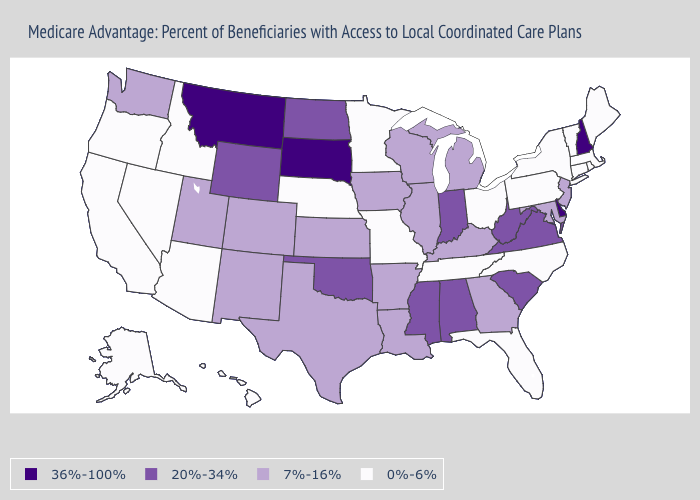What is the value of New Mexico?
Keep it brief. 7%-16%. Name the states that have a value in the range 0%-6%?
Short answer required. Alaska, Arizona, California, Connecticut, Florida, Hawaii, Idaho, Massachusetts, Maine, Minnesota, Missouri, North Carolina, Nebraska, Nevada, New York, Ohio, Oregon, Pennsylvania, Rhode Island, Tennessee, Vermont. Name the states that have a value in the range 0%-6%?
Keep it brief. Alaska, Arizona, California, Connecticut, Florida, Hawaii, Idaho, Massachusetts, Maine, Minnesota, Missouri, North Carolina, Nebraska, Nevada, New York, Ohio, Oregon, Pennsylvania, Rhode Island, Tennessee, Vermont. Which states hav the highest value in the West?
Write a very short answer. Montana. Which states have the lowest value in the USA?
Keep it brief. Alaska, Arizona, California, Connecticut, Florida, Hawaii, Idaho, Massachusetts, Maine, Minnesota, Missouri, North Carolina, Nebraska, Nevada, New York, Ohio, Oregon, Pennsylvania, Rhode Island, Tennessee, Vermont. Name the states that have a value in the range 0%-6%?
Write a very short answer. Alaska, Arizona, California, Connecticut, Florida, Hawaii, Idaho, Massachusetts, Maine, Minnesota, Missouri, North Carolina, Nebraska, Nevada, New York, Ohio, Oregon, Pennsylvania, Rhode Island, Tennessee, Vermont. What is the lowest value in the MidWest?
Answer briefly. 0%-6%. Among the states that border Iowa , does South Dakota have the highest value?
Write a very short answer. Yes. Which states have the lowest value in the West?
Answer briefly. Alaska, Arizona, California, Hawaii, Idaho, Nevada, Oregon. Name the states that have a value in the range 7%-16%?
Give a very brief answer. Arkansas, Colorado, Georgia, Iowa, Illinois, Kansas, Kentucky, Louisiana, Maryland, Michigan, New Jersey, New Mexico, Texas, Utah, Washington, Wisconsin. Name the states that have a value in the range 0%-6%?
Answer briefly. Alaska, Arizona, California, Connecticut, Florida, Hawaii, Idaho, Massachusetts, Maine, Minnesota, Missouri, North Carolina, Nebraska, Nevada, New York, Ohio, Oregon, Pennsylvania, Rhode Island, Tennessee, Vermont. Name the states that have a value in the range 36%-100%?
Concise answer only. Delaware, Montana, New Hampshire, South Dakota. What is the lowest value in the USA?
Answer briefly. 0%-6%. Among the states that border Nebraska , does South Dakota have the highest value?
Give a very brief answer. Yes. What is the highest value in the West ?
Keep it brief. 36%-100%. 